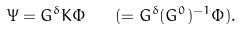Convert formula to latex. <formula><loc_0><loc_0><loc_500><loc_500>\Psi = G ^ { \delta } K \Phi \quad ( = G ^ { \delta } ( G ^ { 0 } ) ^ { - 1 } \Phi ) .</formula> 